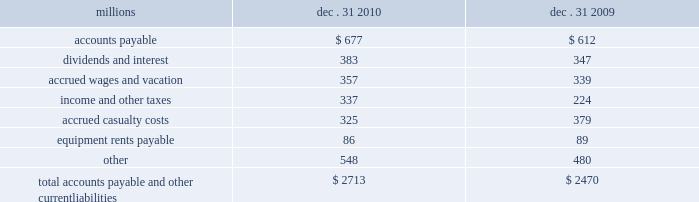Assets held under capital leases are recorded at the lower of the net present value of the minimum lease payments or the fair value of the leased asset at the inception of the lease .
Amortization expense is computed using the straight-line method over the shorter of the estimated useful lives of the assets or the period of the related lease .
12 .
Accounts payable and other current liabilities dec .
31 , dec .
31 , millions 2010 2009 .
13 .
Financial instruments strategy and risk 2013 we may use derivative financial instruments in limited instances for other than trading purposes to assist in managing our overall exposure to fluctuations in interest rates and fuel prices .
We are not a party to leveraged derivatives and , by policy , do not use derivative financial instruments for speculative purposes .
Derivative financial instruments qualifying for hedge accounting must maintain a specified level of effectiveness between the hedging instrument and the item being hedged , both at inception and throughout the hedged period .
We formally document the nature and relationships between the hedging instruments and hedged items at inception , as well as our risk- management objectives , strategies for undertaking the various hedge transactions , and method of assessing hedge effectiveness .
Changes in the fair market value of derivative financial instruments that do not qualify for hedge accounting are charged to earnings .
We may use swaps , collars , futures , and/or forward contracts to mitigate the risk of adverse movements in interest rates and fuel prices ; however , the use of these derivative financial instruments may limit future benefits from favorable interest rate and fuel price movements .
Market and credit risk 2013 we address market risk related to derivative financial instruments by selecting instruments with value fluctuations that highly correlate with the underlying hedged item .
We manage credit risk related to derivative financial instruments , which is minimal , by requiring high credit standards for counterparties and periodic settlements .
At december 31 , 2010 and 2009 , we were not required to provide collateral , nor had we received collateral , relating to our hedging activities .
Determination of fair value 2013 we determine the fair values of our derivative financial instrument positions based upon current fair values as quoted by recognized dealers or the present value of expected future cash flows .
Interest rate fair value hedges 2013 we manage our overall exposure to fluctuations in interest rates by adjusting the proportion of fixed and floating rate debt instruments within our debt portfolio over a given period .
We generally manage the mix of fixed and floating rate debt through the issuance of targeted amounts of each as debt matures or as we require incremental borrowings .
We employ derivatives , primarily swaps , as one of the tools to obtain the targeted mix .
In addition , we also obtain flexibility in managing interest costs and the interest rate mix within our debt portfolio by evaluating the issuance of and managing outstanding callable fixed-rate debt securities .
Swaps allow us to convert debt from fixed rates to variable rates and thereby hedge the risk of changes in the debt 2019s fair value attributable to the changes in interest rates .
We account for swaps as fair value hedges using the short-cut method ; therefore , we do not record any ineffectiveness within our consolidated financial statements. .
In 2010 what was the percent of the total accounts payable and other current liabilities applicable? 
Computations: (677 / 2713)
Answer: 0.24954. Assets held under capital leases are recorded at the lower of the net present value of the minimum lease payments or the fair value of the leased asset at the inception of the lease .
Amortization expense is computed using the straight-line method over the shorter of the estimated useful lives of the assets or the period of the related lease .
12 .
Accounts payable and other current liabilities dec .
31 , dec .
31 , millions 2010 2009 .
13 .
Financial instruments strategy and risk 2013 we may use derivative financial instruments in limited instances for other than trading purposes to assist in managing our overall exposure to fluctuations in interest rates and fuel prices .
We are not a party to leveraged derivatives and , by policy , do not use derivative financial instruments for speculative purposes .
Derivative financial instruments qualifying for hedge accounting must maintain a specified level of effectiveness between the hedging instrument and the item being hedged , both at inception and throughout the hedged period .
We formally document the nature and relationships between the hedging instruments and hedged items at inception , as well as our risk- management objectives , strategies for undertaking the various hedge transactions , and method of assessing hedge effectiveness .
Changes in the fair market value of derivative financial instruments that do not qualify for hedge accounting are charged to earnings .
We may use swaps , collars , futures , and/or forward contracts to mitigate the risk of adverse movements in interest rates and fuel prices ; however , the use of these derivative financial instruments may limit future benefits from favorable interest rate and fuel price movements .
Market and credit risk 2013 we address market risk related to derivative financial instruments by selecting instruments with value fluctuations that highly correlate with the underlying hedged item .
We manage credit risk related to derivative financial instruments , which is minimal , by requiring high credit standards for counterparties and periodic settlements .
At december 31 , 2010 and 2009 , we were not required to provide collateral , nor had we received collateral , relating to our hedging activities .
Determination of fair value 2013 we determine the fair values of our derivative financial instrument positions based upon current fair values as quoted by recognized dealers or the present value of expected future cash flows .
Interest rate fair value hedges 2013 we manage our overall exposure to fluctuations in interest rates by adjusting the proportion of fixed and floating rate debt instruments within our debt portfolio over a given period .
We generally manage the mix of fixed and floating rate debt through the issuance of targeted amounts of each as debt matures or as we require incremental borrowings .
We employ derivatives , primarily swaps , as one of the tools to obtain the targeted mix .
In addition , we also obtain flexibility in managing interest costs and the interest rate mix within our debt portfolio by evaluating the issuance of and managing outstanding callable fixed-rate debt securities .
Swaps allow us to convert debt from fixed rates to variable rates and thereby hedge the risk of changes in the debt 2019s fair value attributable to the changes in interest rates .
We account for swaps as fair value hedges using the short-cut method ; therefore , we do not record any ineffectiveness within our consolidated financial statements. .
In millions , what is the range for accrued wages and vacation from 2009-2010? 
Computations: (357 - 339)
Answer: 18.0. 